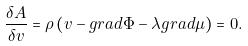<formula> <loc_0><loc_0><loc_500><loc_500>\frac { \delta A } { \delta { v } } = \rho \left ( { v } - { g r a d } \Phi - \lambda { g r a d } \mu \right ) = 0 .</formula> 